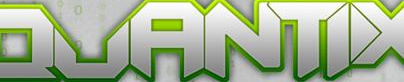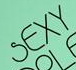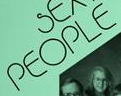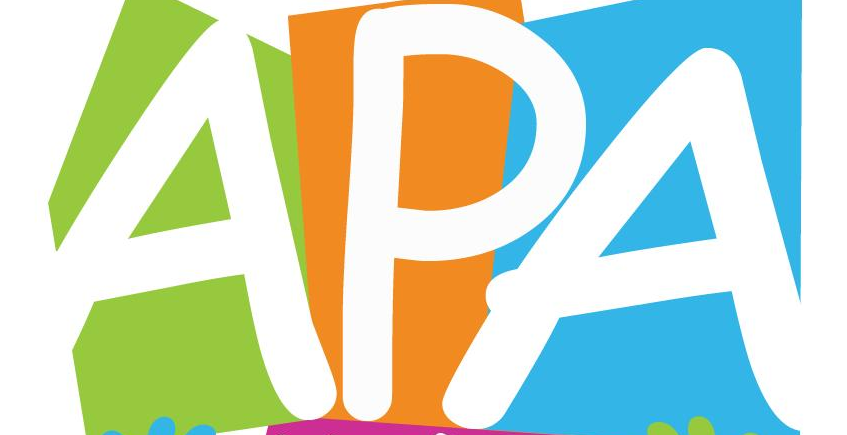Read the text content from these images in order, separated by a semicolon. QUANTIX; SEXY; PEOPLE; APA 